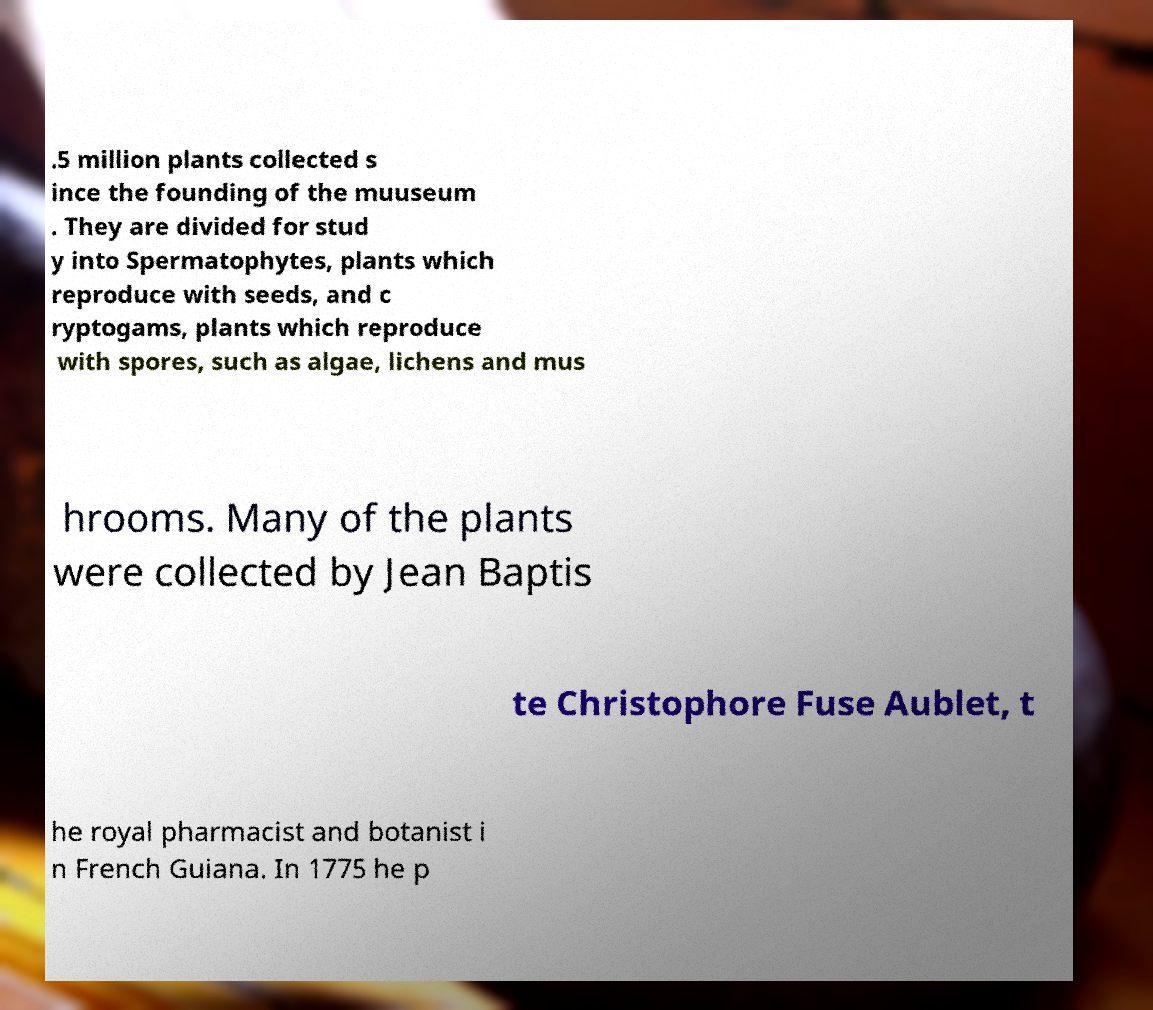What messages or text are displayed in this image? I need them in a readable, typed format. .5 million plants collected s ince the founding of the muuseum . They are divided for stud y into Spermatophytes, plants which reproduce with seeds, and c ryptogams, plants which reproduce with spores, such as algae, lichens and mus hrooms. Many of the plants were collected by Jean Baptis te Christophore Fuse Aublet, t he royal pharmacist and botanist i n French Guiana. In 1775 he p 